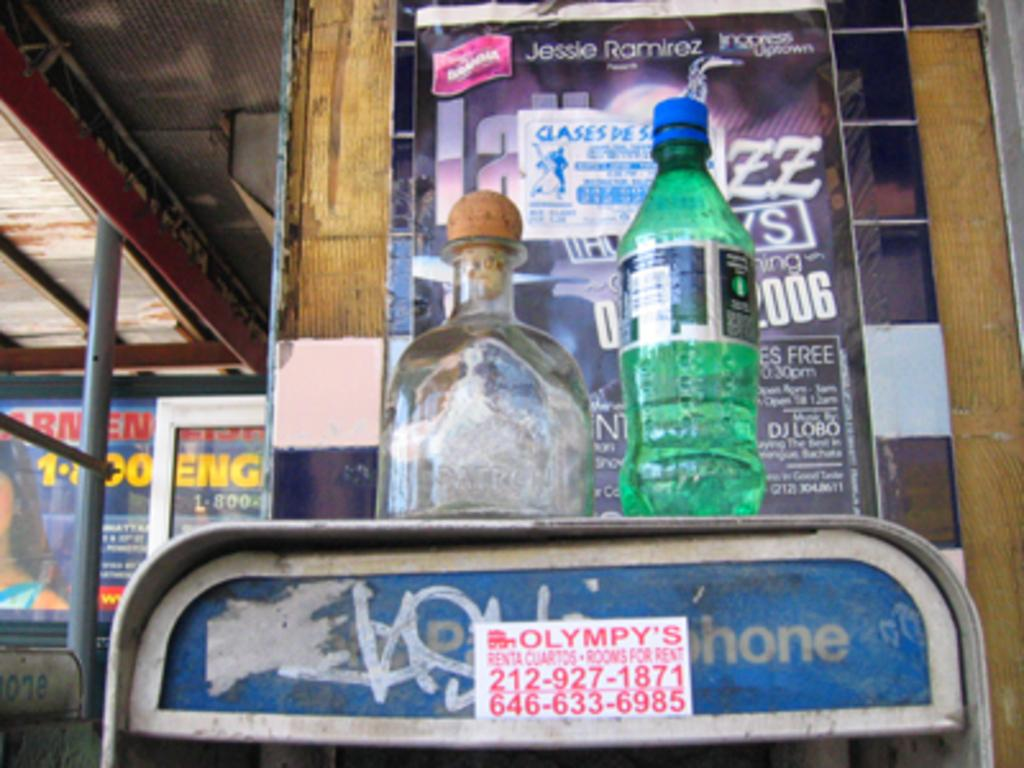<image>
Provide a brief description of the given image. Two sodas on a phone stand with a sticker that says Olympy's. 